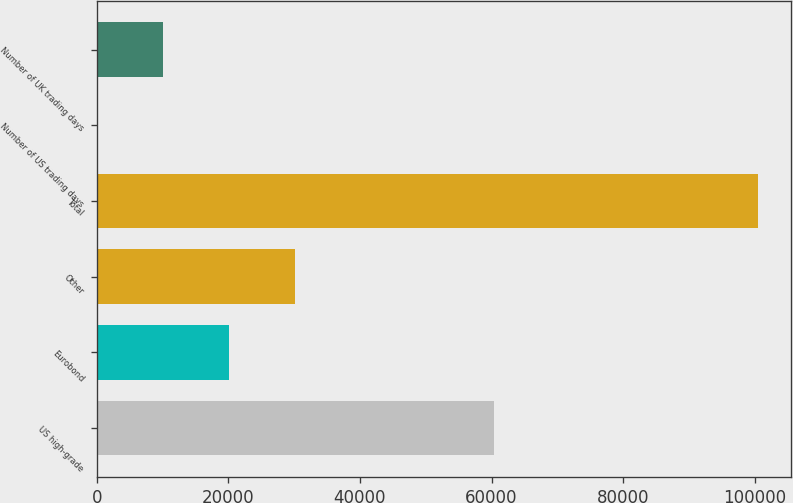Convert chart to OTSL. <chart><loc_0><loc_0><loc_500><loc_500><bar_chart><fcel>US high-grade<fcel>Eurobond<fcel>Other<fcel>Total<fcel>Number of US trading days<fcel>Number of UK trading days<nl><fcel>60387<fcel>20141.2<fcel>30179.8<fcel>100450<fcel>64<fcel>10102.6<nl></chart> 